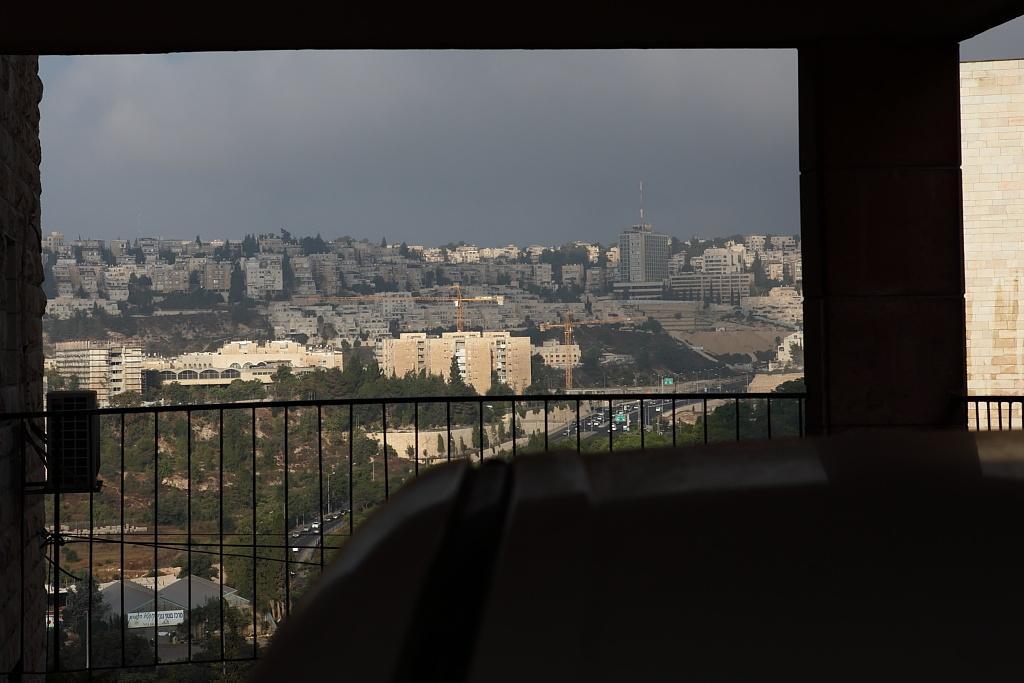Please provide a concise description of this image. In this image there is one object on the bottom of this image. There is a fencing gate at left side to this object. There are some trees and buildings in the background. There is sky on the top of this image. There is a wall on the right side of this image. 